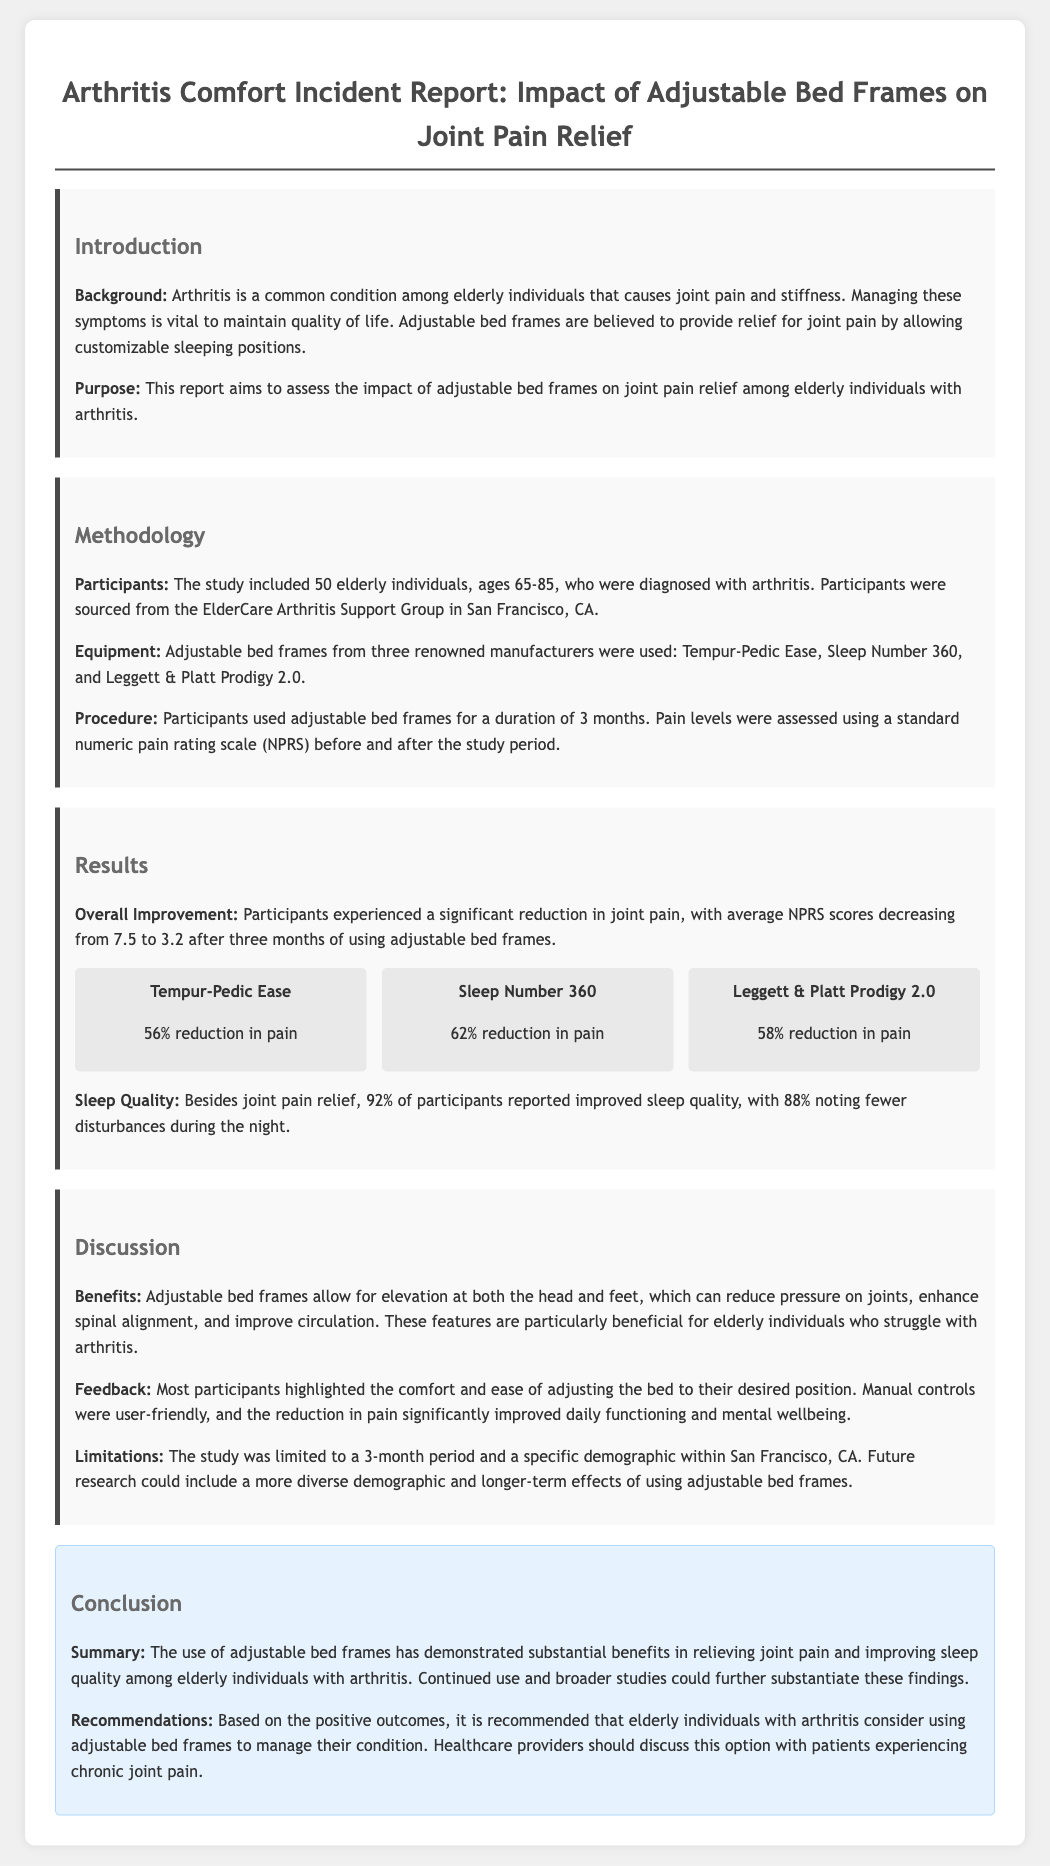What was the age range of participants in the study? The participants were elderly individuals ages 65-85.
Answer: 65-85 How many participants were included in the study? The study included a total of 50 elderly individuals.
Answer: 50 What tool was used to assess pain levels? Pain levels were assessed using a standard numeric pain rating scale (NPRS).
Answer: NPRS Which adjustable bed frame had the highest pain reduction percentage? Sleep Number 360 had a 62% reduction in pain, which is the highest among the three mentioned.
Answer: 62% What percentage of participants reported improved sleep quality? 92% of participants reported improved sleep quality.
Answer: 92% What is a significant benefit of adjustable bed frames mentioned in the report? Adjustable bed frames reduce pressure on joints and enhance spinal alignment.
Answer: Reduce pressure on joints What is a limitation of the study? The study was limited to a 3-month period and a specific demographic within San Francisco, CA.
Answer: 3-month period What is the overall improvement in pain scores after using the adjustable bed frames? Average NPRS scores decreased from 7.5 to 3.2.
Answer: 7.5 to 3.2 What recommendation is made for elderly individuals experiencing chronic joint pain? It is recommended that elderly individuals consider using adjustable bed frames.
Answer: Consider using adjustable bed frames 